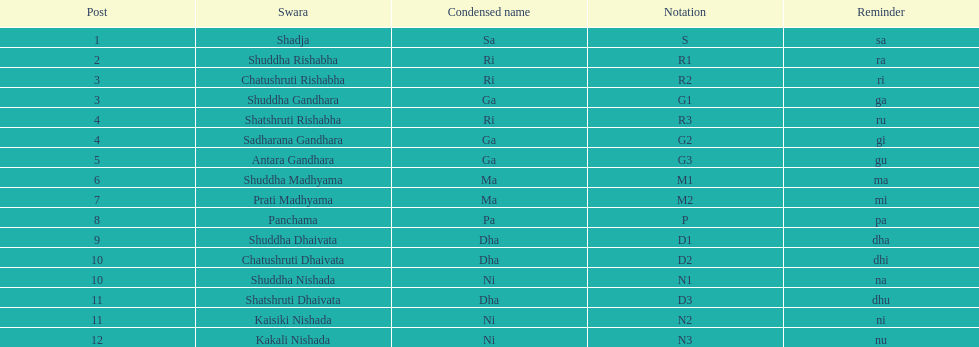Find the 9th position swara. what is its short name? Dha. 